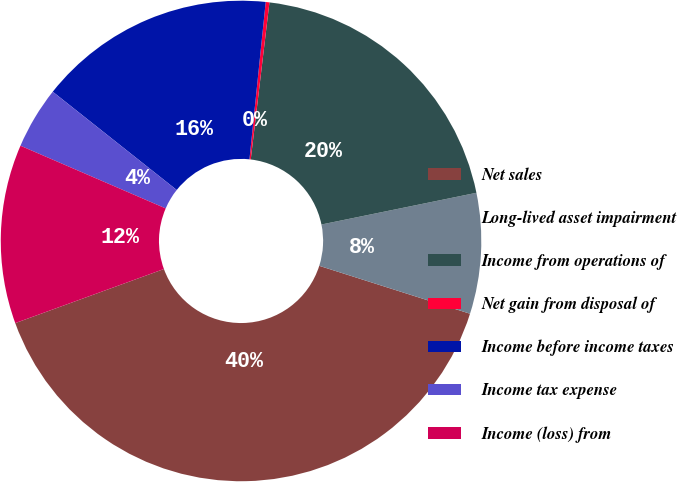Convert chart. <chart><loc_0><loc_0><loc_500><loc_500><pie_chart><fcel>Net sales<fcel>Long-lived asset impairment<fcel>Income from operations of<fcel>Net gain from disposal of<fcel>Income before income taxes<fcel>Income tax expense<fcel>Income (loss) from<nl><fcel>39.55%<fcel>8.11%<fcel>19.9%<fcel>0.25%<fcel>15.97%<fcel>4.18%<fcel>12.04%<nl></chart> 